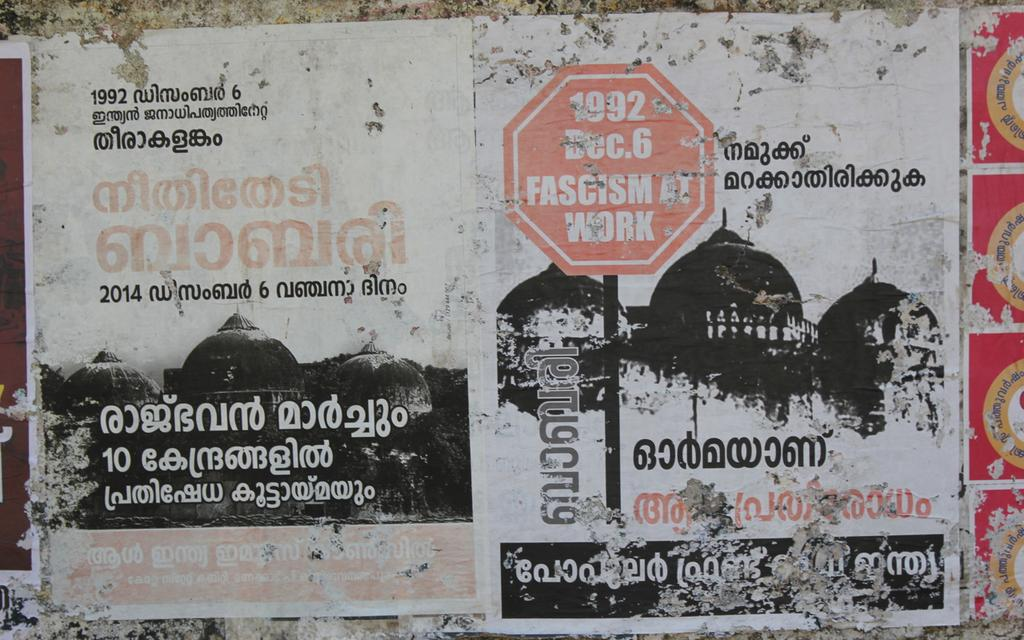Provide a one-sentence caption for the provided image. A ragged poster with a stop sign that reads 1922 Dec. 6 sits against a wall. 